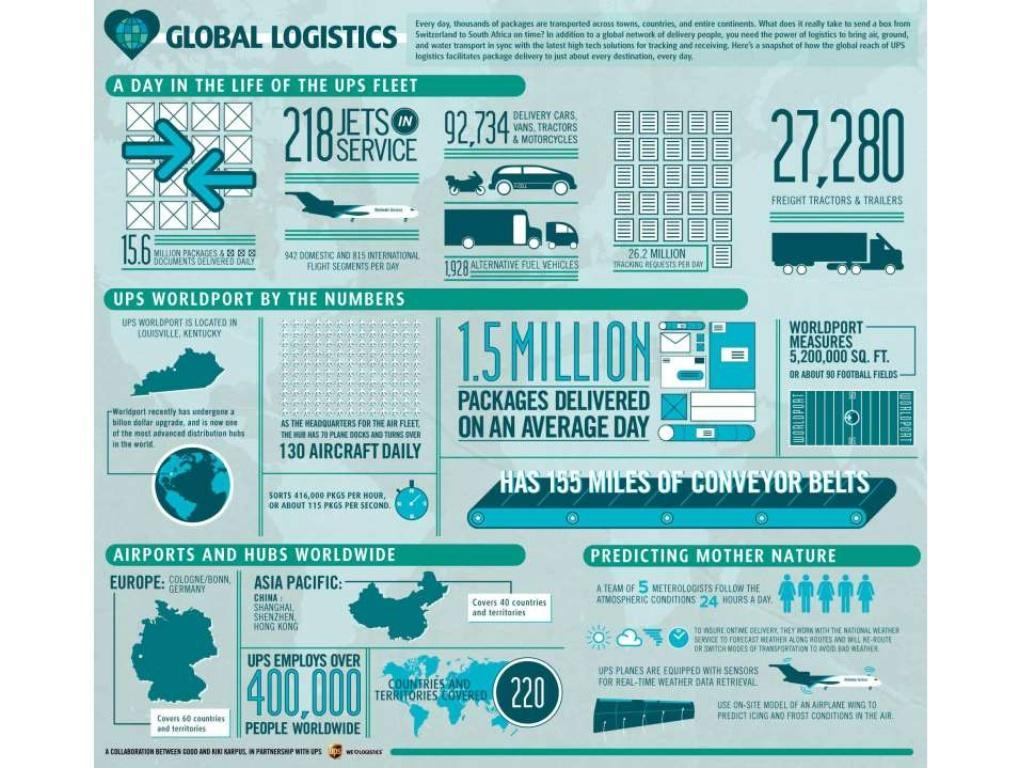What is the number of freight tractors & trailers available in the UPS logistic company?
Answer the question with a short phrase. 27,280 What is the total number of people employed in the UPS logistics company around the world? OVER 400,000 How many countries & territories worldwide were covered by the UPS logistics? 220 How many packets are delivered on an average day by the UPS? 1.5 MILLION 